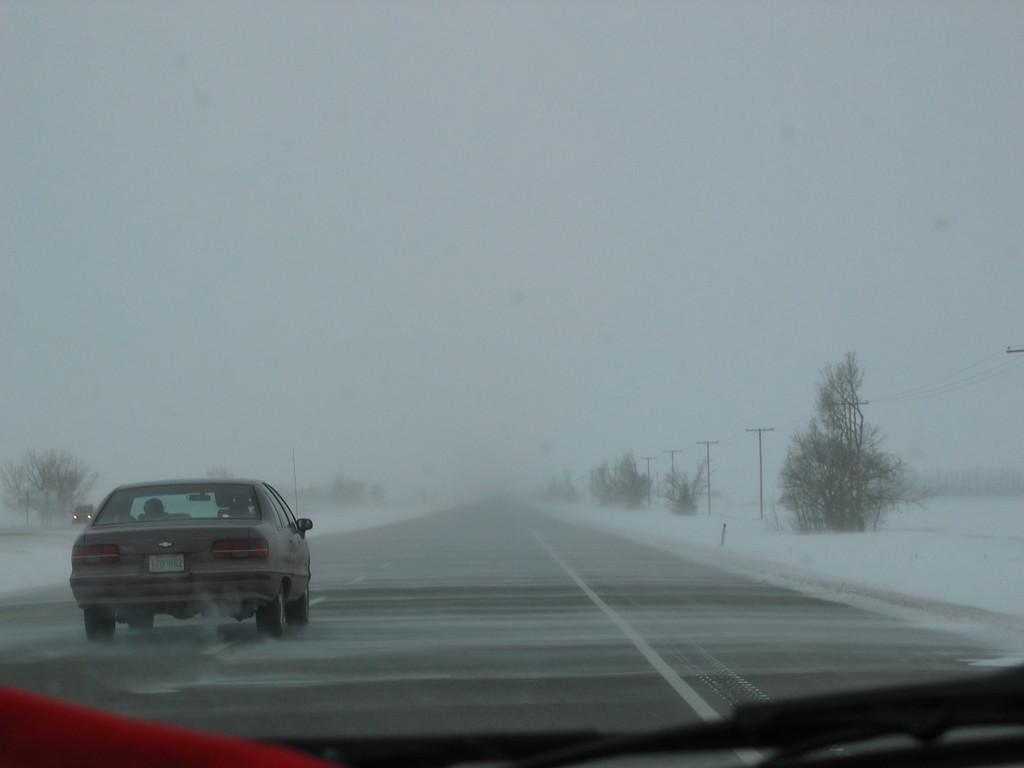What is on the road in the image? There is a vehicle on the road in the image. What type of natural elements can be seen in the image? There are trees in the image. What man-made structures are present in the image? There are current poles in the image. What weather condition is depicted in the image? The image shows snow. How many giants can be seen walking through the snow in the image? There are no giants present in the image; it only shows a vehicle on the road, trees, current poles, and snow. 